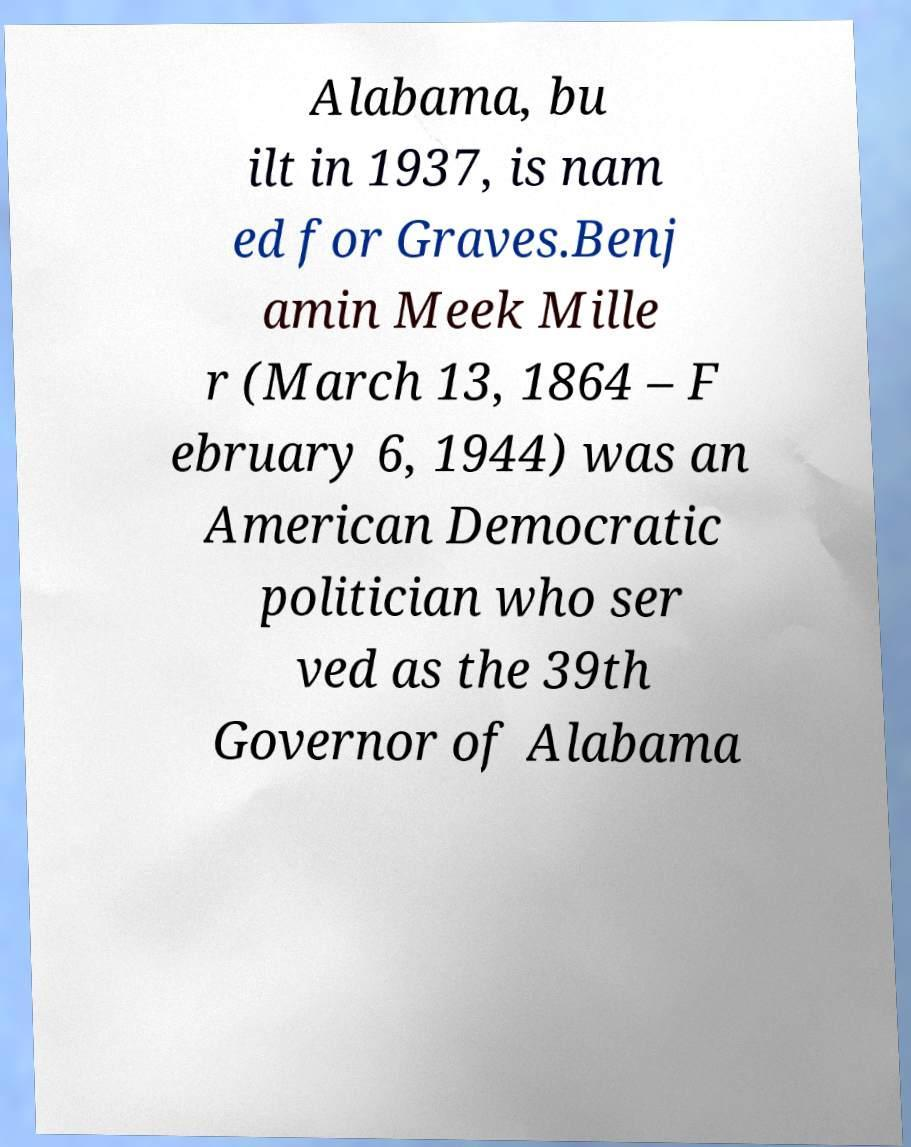Can you read and provide the text displayed in the image?This photo seems to have some interesting text. Can you extract and type it out for me? Alabama, bu ilt in 1937, is nam ed for Graves.Benj amin Meek Mille r (March 13, 1864 – F ebruary 6, 1944) was an American Democratic politician who ser ved as the 39th Governor of Alabama 